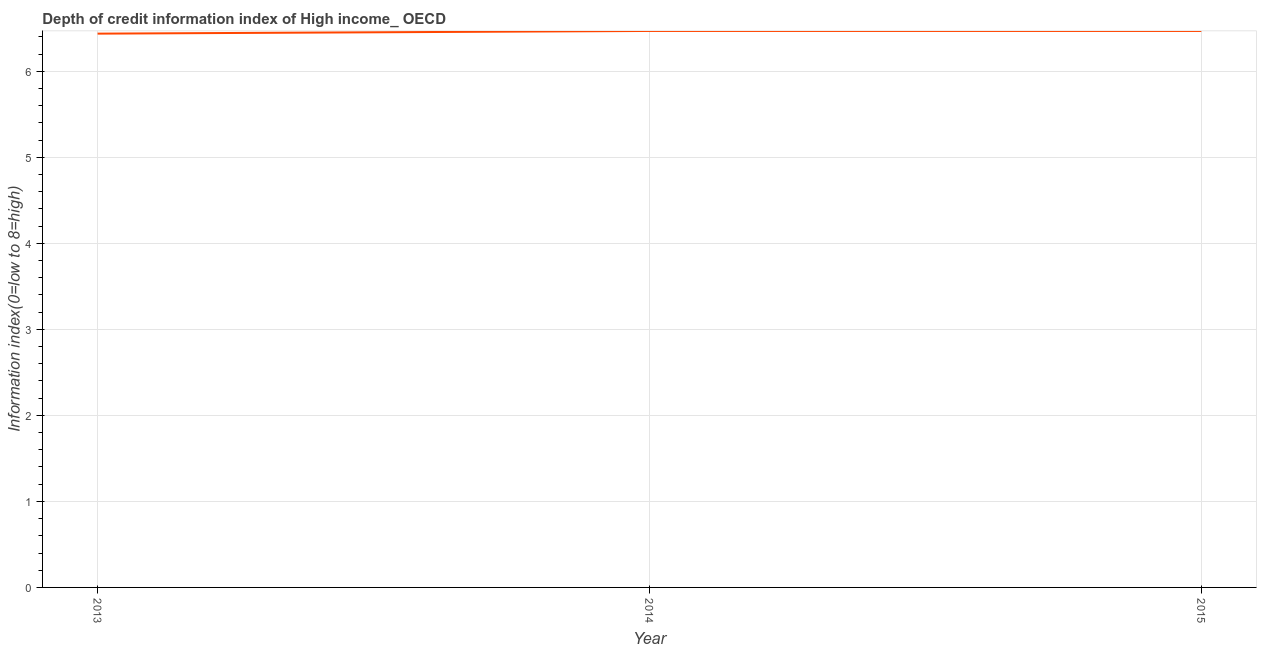What is the depth of credit information index in 2014?
Give a very brief answer. 6.47. Across all years, what is the maximum depth of credit information index?
Your answer should be very brief. 6.47. Across all years, what is the minimum depth of credit information index?
Offer a very short reply. 6.44. In which year was the depth of credit information index minimum?
Make the answer very short. 2013. What is the sum of the depth of credit information index?
Provide a succinct answer. 19.38. What is the difference between the depth of credit information index in 2013 and 2015?
Your response must be concise. -0.03. What is the average depth of credit information index per year?
Make the answer very short. 6.46. What is the median depth of credit information index?
Ensure brevity in your answer.  6.47. What is the ratio of the depth of credit information index in 2013 to that in 2015?
Your response must be concise. 1. What is the difference between the highest and the lowest depth of credit information index?
Offer a very short reply. 0.03. In how many years, is the depth of credit information index greater than the average depth of credit information index taken over all years?
Your response must be concise. 2. How many lines are there?
Make the answer very short. 1. How many years are there in the graph?
Ensure brevity in your answer.  3. Are the values on the major ticks of Y-axis written in scientific E-notation?
Keep it short and to the point. No. Does the graph contain any zero values?
Your answer should be very brief. No. What is the title of the graph?
Provide a short and direct response. Depth of credit information index of High income_ OECD. What is the label or title of the Y-axis?
Provide a succinct answer. Information index(0=low to 8=high). What is the Information index(0=low to 8=high) in 2013?
Offer a terse response. 6.44. What is the Information index(0=low to 8=high) in 2014?
Offer a very short reply. 6.47. What is the Information index(0=low to 8=high) of 2015?
Keep it short and to the point. 6.47. What is the difference between the Information index(0=low to 8=high) in 2013 and 2014?
Provide a short and direct response. -0.03. What is the difference between the Information index(0=low to 8=high) in 2013 and 2015?
Provide a succinct answer. -0.03. What is the ratio of the Information index(0=low to 8=high) in 2013 to that in 2015?
Give a very brief answer. 0.99. 